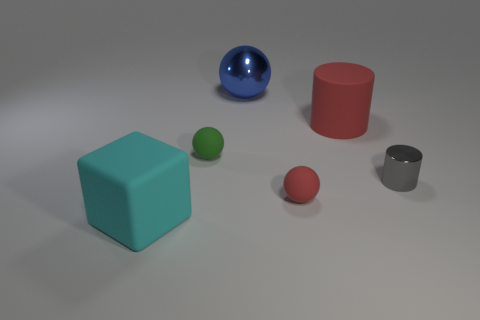What material is the object that is the same color as the rubber cylinder?
Provide a short and direct response. Rubber. Are there any other things that have the same shape as the large blue metal thing?
Your response must be concise. Yes. There is a metal object that is to the right of the matte ball that is in front of the tiny metallic object; what size is it?
Your answer should be very brief. Small. What number of tiny things are cyan objects or red rubber cylinders?
Provide a short and direct response. 0. Is the number of green spheres less than the number of matte things?
Make the answer very short. Yes. Are there more large shiny balls than gray metallic spheres?
Give a very brief answer. Yes. How many other objects are there of the same color as the matte cylinder?
Keep it short and to the point. 1. There is a big rubber thing to the right of the big cyan thing; what number of rubber cylinders are left of it?
Provide a succinct answer. 0. Are there any blue balls to the right of the small green matte object?
Provide a succinct answer. Yes. There is a shiny thing left of the matte object behind the small green thing; what shape is it?
Offer a very short reply. Sphere. 